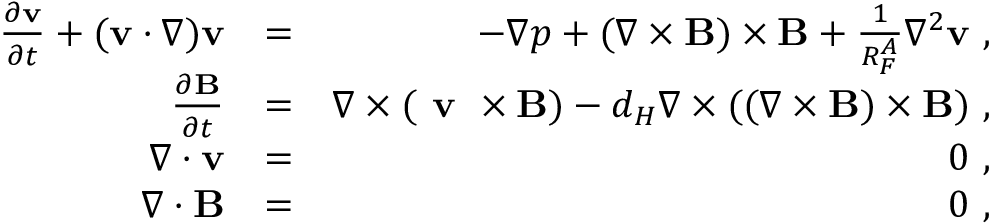Convert formula to latex. <formula><loc_0><loc_0><loc_500><loc_500>\begin{array} { r l r } { \frac { \partial { v } } { \partial t } + ( { v } \cdot \nabla ) { v } } & { = } & { - \nabla p + ( \nabla \times { B } ) \times { B } + \frac { 1 } { R _ { F } ^ { A } } \nabla ^ { 2 } { v } , } \\ { \frac { \partial { B } } { \partial t } } & { = } & { \nabla \times ( v \times { B } ) - d _ { H } \nabla \times ( ( \nabla \times { B } ) \times { B } ) , } \\ { \nabla \cdot { v } } & { = } & { 0 , } \\ { \nabla \cdot { B } } & { = } & { 0 , } \end{array}</formula> 